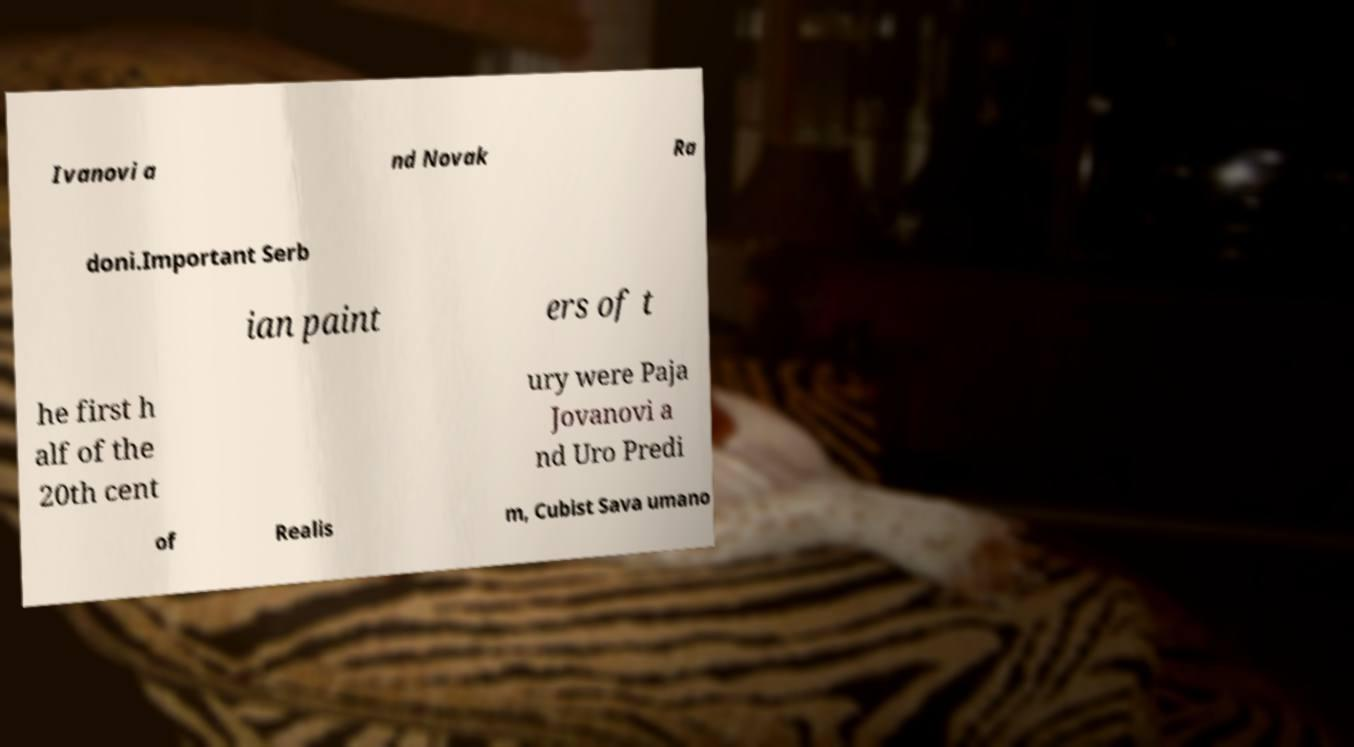Can you accurately transcribe the text from the provided image for me? Ivanovi a nd Novak Ra doni.Important Serb ian paint ers of t he first h alf of the 20th cent ury were Paja Jovanovi a nd Uro Predi of Realis m, Cubist Sava umano 